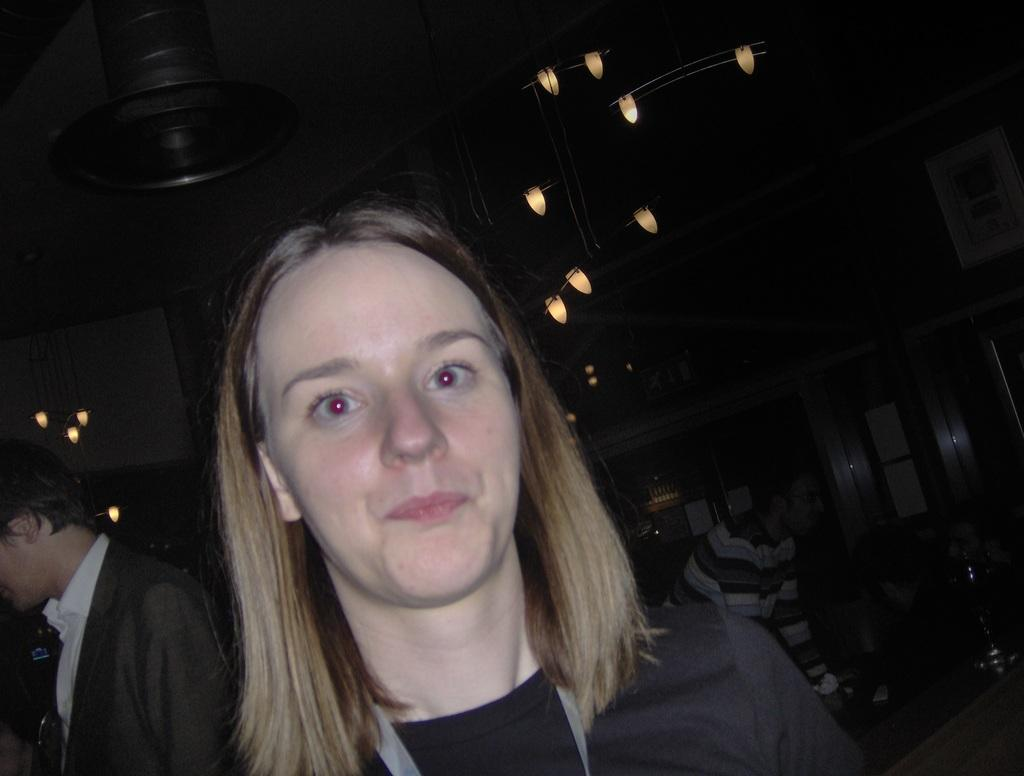What can be observed about the people in the image? There are people with different color dresses in the image. What is visible in the top part of the image? There are lights visible in the top of the image. What is attached to the wall in the image? There are boards on the wall in the image. What is the color of the background in the image? The background of the image is black. What type of horn can be heard in the image? There is no horn present in the image, and therefore no sound can be heard. 